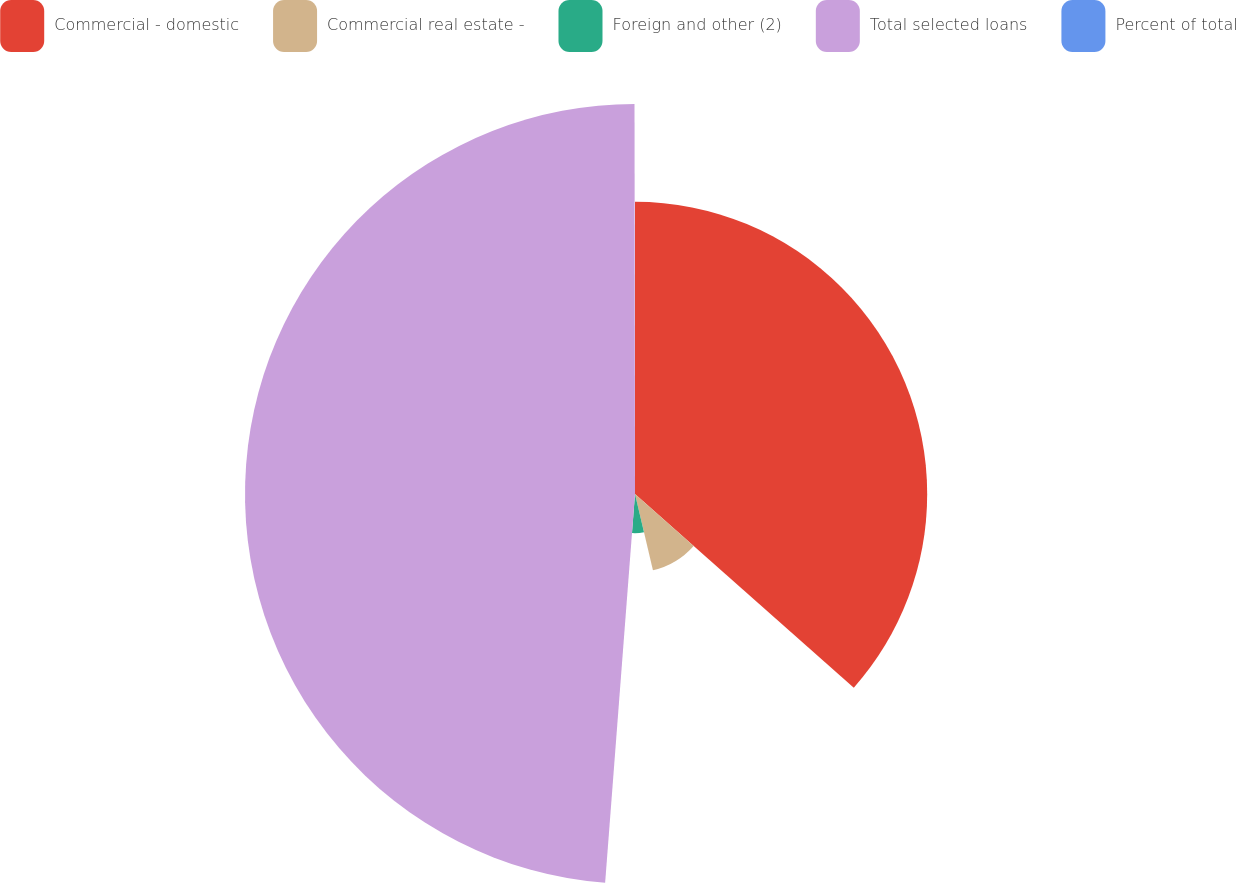<chart> <loc_0><loc_0><loc_500><loc_500><pie_chart><fcel>Commercial - domestic<fcel>Commercial real estate -<fcel>Foreign and other (2)<fcel>Total selected loans<fcel>Percent of total<nl><fcel>36.53%<fcel>9.79%<fcel>4.9%<fcel>48.76%<fcel>0.02%<nl></chart> 